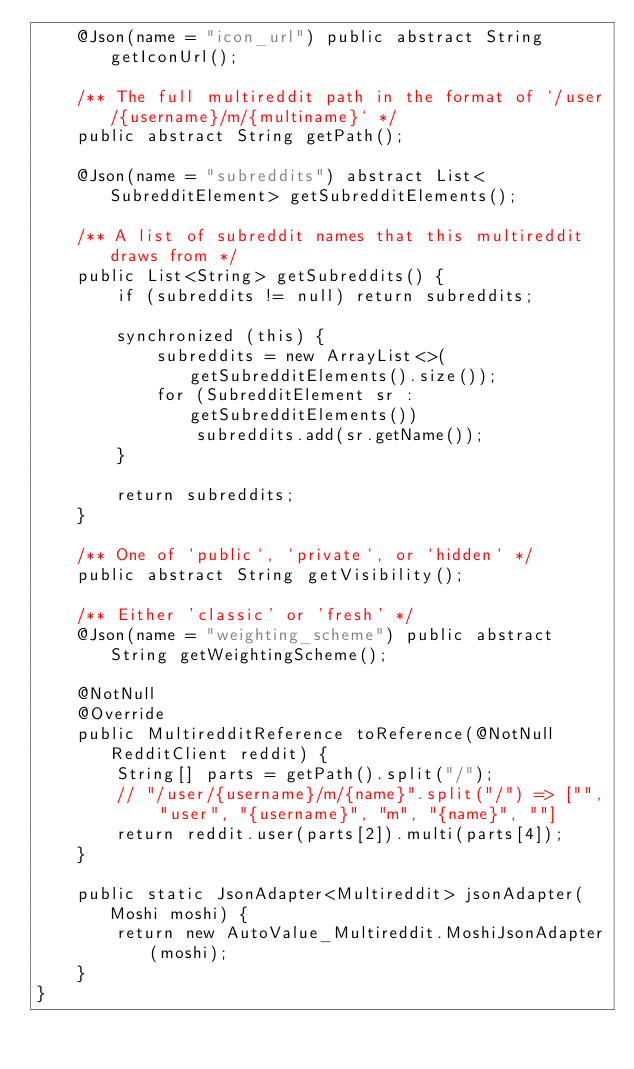Convert code to text. <code><loc_0><loc_0><loc_500><loc_500><_Java_>    @Json(name = "icon_url") public abstract String getIconUrl();

    /** The full multireddit path in the format of `/user/{username}/m/{multiname}` */
    public abstract String getPath();

    @Json(name = "subreddits") abstract List<SubredditElement> getSubredditElements();

    /** A list of subreddit names that this multireddit draws from */
    public List<String> getSubreddits() {
        if (subreddits != null) return subreddits;

        synchronized (this) {
            subreddits = new ArrayList<>(getSubredditElements().size());
            for (SubredditElement sr : getSubredditElements())
                subreddits.add(sr.getName());
        }

        return subreddits;
    }

    /** One of `public`, `private`, or `hidden` */
    public abstract String getVisibility();

    /** Either 'classic' or 'fresh' */
    @Json(name = "weighting_scheme") public abstract String getWeightingScheme();

    @NotNull
    @Override
    public MultiredditReference toReference(@NotNull RedditClient reddit) {
        String[] parts = getPath().split("/");
        // "/user/{username}/m/{name}".split("/") => ["", "user", "{username}", "m", "{name}", ""]
        return reddit.user(parts[2]).multi(parts[4]);
    }

    public static JsonAdapter<Multireddit> jsonAdapter(Moshi moshi) {
        return new AutoValue_Multireddit.MoshiJsonAdapter(moshi);
    }
}
</code> 